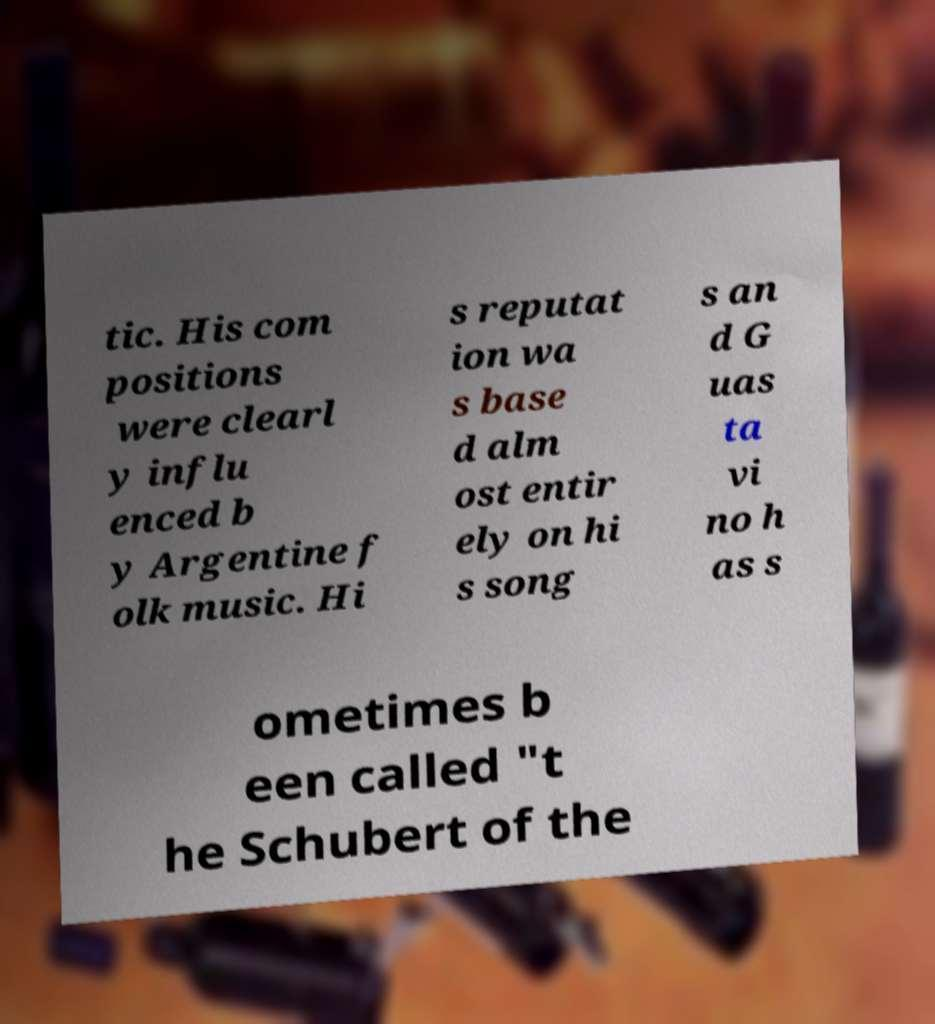Can you read and provide the text displayed in the image?This photo seems to have some interesting text. Can you extract and type it out for me? tic. His com positions were clearl y influ enced b y Argentine f olk music. Hi s reputat ion wa s base d alm ost entir ely on hi s song s an d G uas ta vi no h as s ometimes b een called "t he Schubert of the 